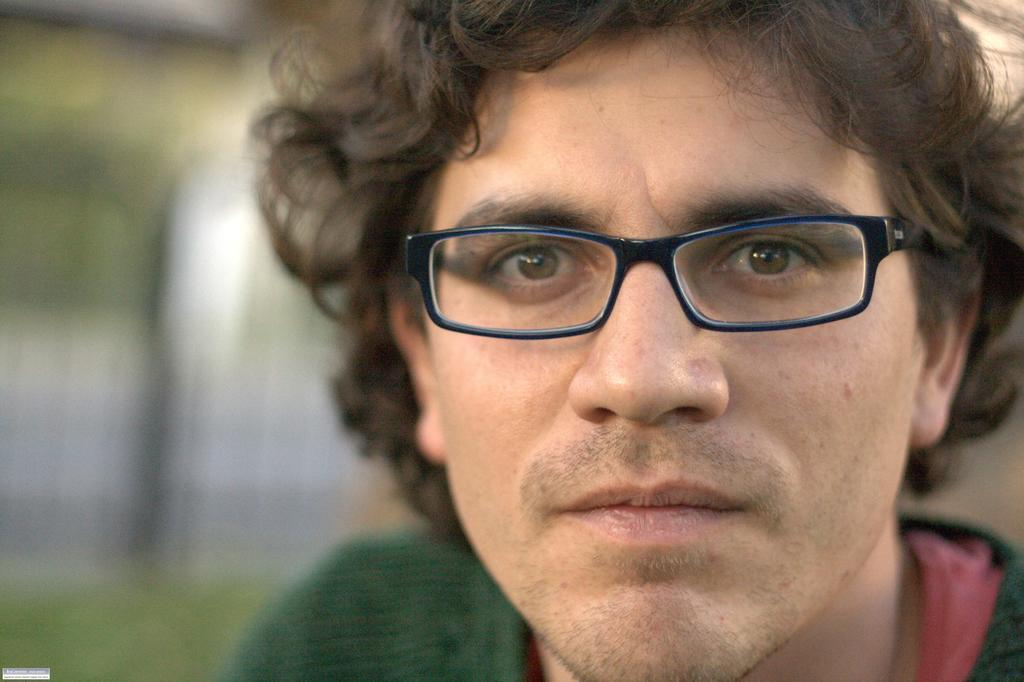What is the main subject in the foreground of the picture? There is a man in the foreground of the picture. What is the man wearing in the image? The man is wearing a green T-shirt and spectacles. Can you describe the background of the image? The background of the image is blurred. Where is the toothpaste placed on the desk in the image? There is no desk or toothpaste present in the image. Can you describe the color and fragrance of the rose in the image? There is no rose present in the image. 